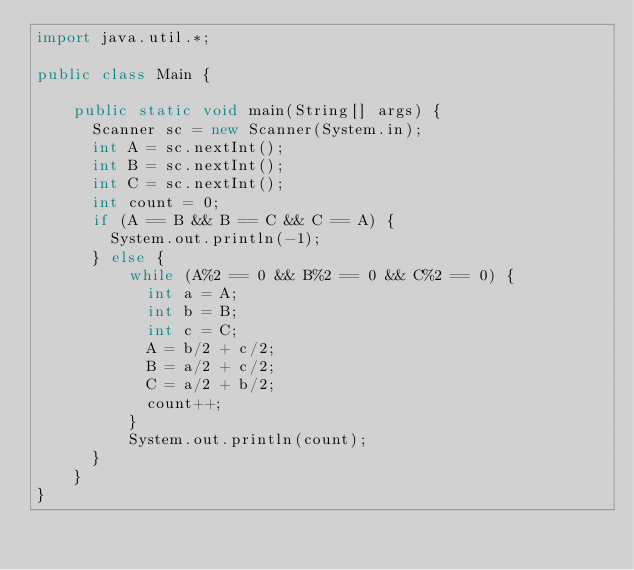<code> <loc_0><loc_0><loc_500><loc_500><_Java_>import java.util.*;
 
public class Main {
	
    public static void main(String[] args) {
    	Scanner sc = new Scanner(System.in);
    	int A = sc.nextInt();
    	int B = sc.nextInt();
    	int C = sc.nextInt();
    	int count = 0;
    	if (A == B && B == C && C == A) {
    		System.out.println(-1);
    	} else {
        	while (A%2 == 0 && B%2 == 0 && C%2 == 0) {
        		int a = A;
        		int b = B;
        		int c = C;
        		A = b/2 + c/2;
        		B = a/2 + c/2;
        		C = a/2 + b/2;
        		count++;
        	}
        	System.out.println(count);
    	}
    }
}</code> 